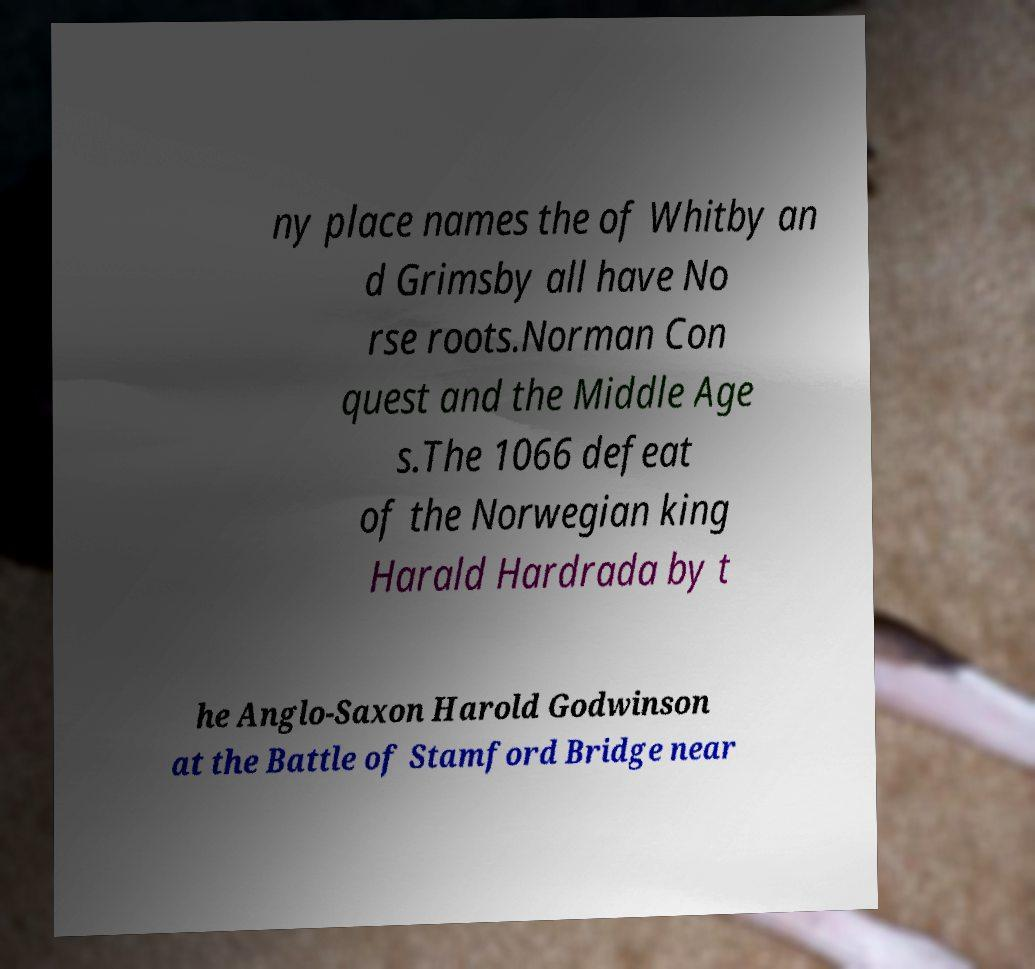Can you accurately transcribe the text from the provided image for me? ny place names the of Whitby an d Grimsby all have No rse roots.Norman Con quest and the Middle Age s.The 1066 defeat of the Norwegian king Harald Hardrada by t he Anglo-Saxon Harold Godwinson at the Battle of Stamford Bridge near 